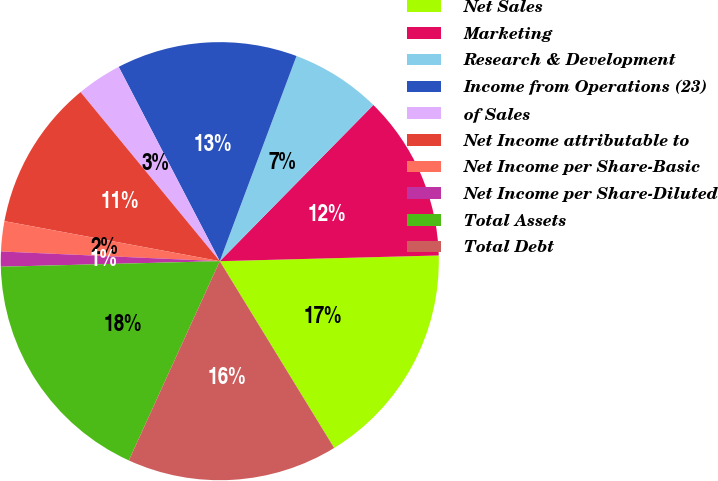<chart> <loc_0><loc_0><loc_500><loc_500><pie_chart><fcel>Net Sales<fcel>Marketing<fcel>Research & Development<fcel>Income from Operations (23)<fcel>of Sales<fcel>Net Income attributable to<fcel>Net Income per Share-Basic<fcel>Net Income per Share-Diluted<fcel>Total Assets<fcel>Total Debt<nl><fcel>16.67%<fcel>12.22%<fcel>6.67%<fcel>13.33%<fcel>3.33%<fcel>11.11%<fcel>2.22%<fcel>1.11%<fcel>17.78%<fcel>15.56%<nl></chart> 